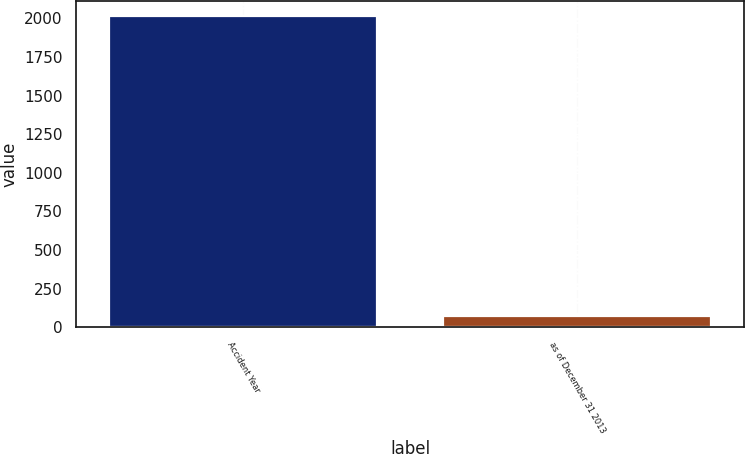<chart> <loc_0><loc_0><loc_500><loc_500><bar_chart><fcel>Accident Year<fcel>as of December 31 2013<nl><fcel>2012<fcel>72.7<nl></chart> 